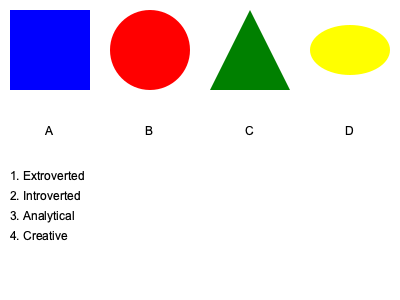As a clinical psychologist, match each personality trait (1-4) with the most appropriate abstract symbol (A-D) based on psychological principles and visual metaphors. Provide your answer as a series of number-letter pairs (e.g., 1A, 2B, 3C, 4D). To match personality traits with abstract symbols, we need to consider the psychological principles and visual metaphors associated with each:

1. Extroverted: This trait is best represented by the red circle (B). Circles are often associated with social connections and outward energy. The vibrant red color also symbolizes enthusiasm and outgoing nature.

2. Introverted: The blue square (A) best represents this trait. Squares are stable and contained, reflecting the inward focus of introverts. The cool blue color suggests calmness and introspection.

3. Analytical: The green triangle (C) is most suitable for this trait. Triangles are associated with logical thinking and problem-solving. The sharp edges represent precision, while green can symbolize growth and balance in decision-making.

4. Creative: The yellow ellipse (D) best represents creativity. The dynamic, irregular shape of an ellipse suggests flexibility and unconventional thinking. Yellow is often associated with imagination and innovation.

By considering the shape, color, and psychological associations of each symbol, we can logically pair them with the corresponding personality traits.
Answer: 1B, 2A, 3C, 4D 